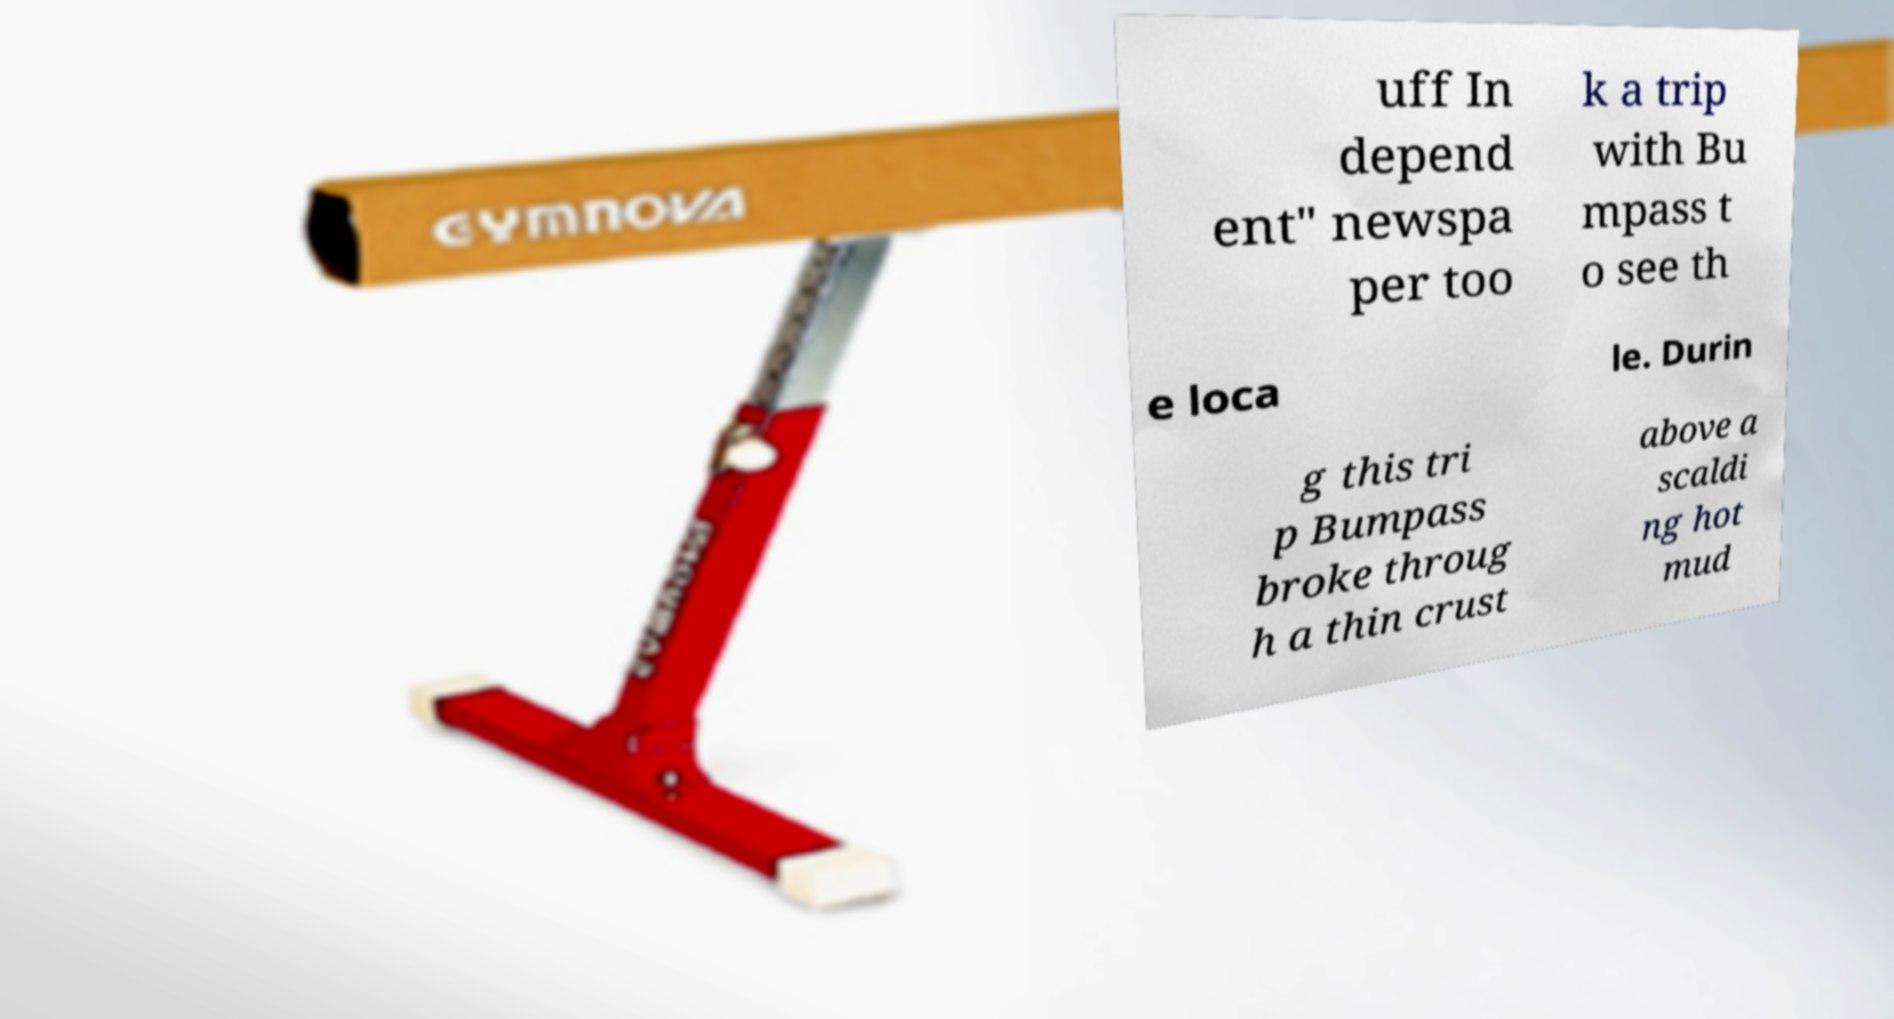Can you read and provide the text displayed in the image?This photo seems to have some interesting text. Can you extract and type it out for me? uff In depend ent" newspa per too k a trip with Bu mpass t o see th e loca le. Durin g this tri p Bumpass broke throug h a thin crust above a scaldi ng hot mud 